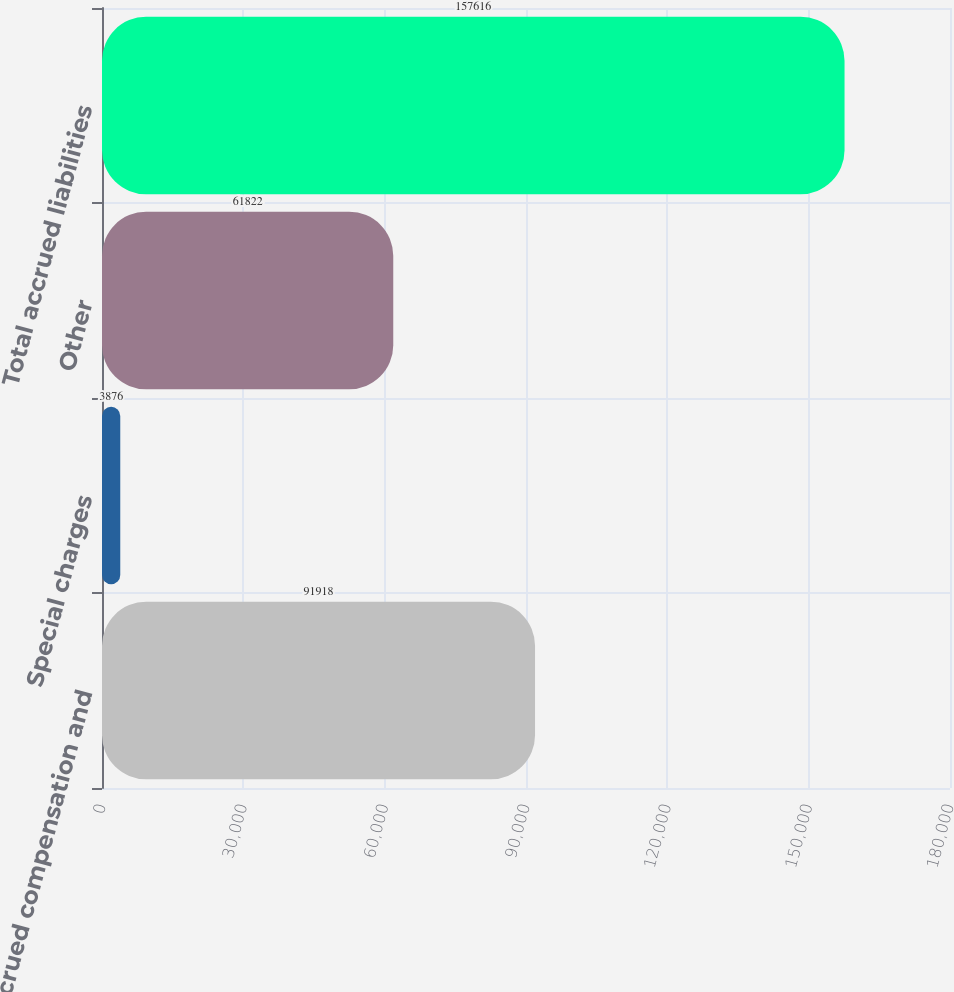Convert chart. <chart><loc_0><loc_0><loc_500><loc_500><bar_chart><fcel>Accrued compensation and<fcel>Special charges<fcel>Other<fcel>Total accrued liabilities<nl><fcel>91918<fcel>3876<fcel>61822<fcel>157616<nl></chart> 